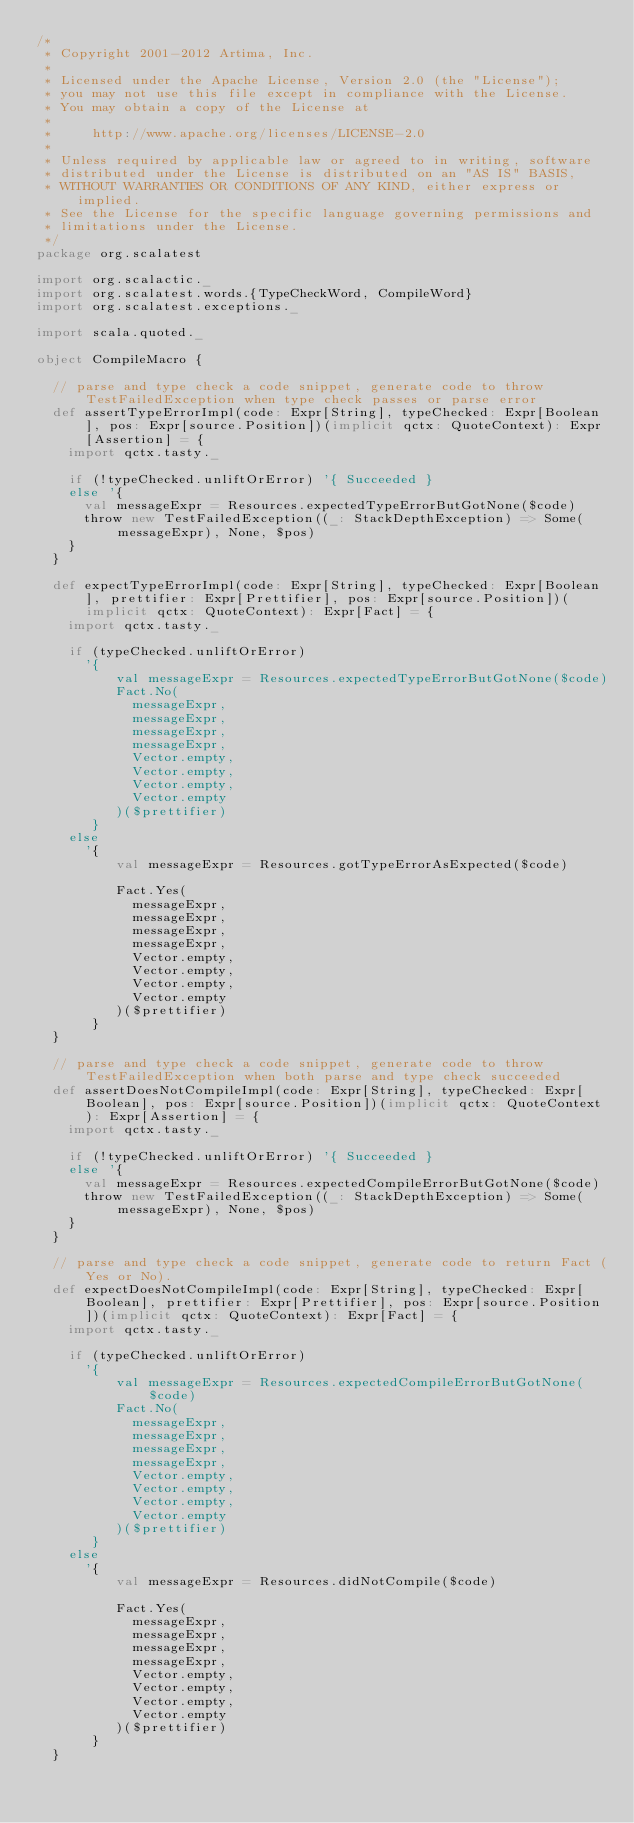<code> <loc_0><loc_0><loc_500><loc_500><_Scala_>/*
 * Copyright 2001-2012 Artima, Inc.
 *
 * Licensed under the Apache License, Version 2.0 (the "License");
 * you may not use this file except in compliance with the License.
 * You may obtain a copy of the License at
 *
 *     http://www.apache.org/licenses/LICENSE-2.0
 *
 * Unless required by applicable law or agreed to in writing, software
 * distributed under the License is distributed on an "AS IS" BASIS,
 * WITHOUT WARRANTIES OR CONDITIONS OF ANY KIND, either express or implied.
 * See the License for the specific language governing permissions and
 * limitations under the License.
 */
package org.scalatest

import org.scalactic._
import org.scalatest.words.{TypeCheckWord, CompileWord}
import org.scalatest.exceptions._

import scala.quoted._

object CompileMacro {

  // parse and type check a code snippet, generate code to throw TestFailedException when type check passes or parse error
  def assertTypeErrorImpl(code: Expr[String], typeChecked: Expr[Boolean], pos: Expr[source.Position])(implicit qctx: QuoteContext): Expr[Assertion] = {
    import qctx.tasty._

    if (!typeChecked.unliftOrError) '{ Succeeded }
    else '{
      val messageExpr = Resources.expectedTypeErrorButGotNone($code)
      throw new TestFailedException((_: StackDepthException) => Some(messageExpr), None, $pos)
    }
  }

  def expectTypeErrorImpl(code: Expr[String], typeChecked: Expr[Boolean], prettifier: Expr[Prettifier], pos: Expr[source.Position])(implicit qctx: QuoteContext): Expr[Fact] = {
    import qctx.tasty._

    if (typeChecked.unliftOrError)
      '{
          val messageExpr = Resources.expectedTypeErrorButGotNone($code)
          Fact.No(
            messageExpr,
            messageExpr,
            messageExpr,
            messageExpr,
            Vector.empty,
            Vector.empty,
            Vector.empty,
            Vector.empty
          )($prettifier)
       }
    else
      '{
          val messageExpr = Resources.gotTypeErrorAsExpected($code)

          Fact.Yes(
            messageExpr,
            messageExpr,
            messageExpr,
            messageExpr,
            Vector.empty,
            Vector.empty,
            Vector.empty,
            Vector.empty
          )($prettifier)
       }
  }

  // parse and type check a code snippet, generate code to throw TestFailedException when both parse and type check succeeded
  def assertDoesNotCompileImpl(code: Expr[String], typeChecked: Expr[Boolean], pos: Expr[source.Position])(implicit qctx: QuoteContext): Expr[Assertion] = {
    import qctx.tasty._

    if (!typeChecked.unliftOrError) '{ Succeeded }
    else '{
      val messageExpr = Resources.expectedCompileErrorButGotNone($code)
      throw new TestFailedException((_: StackDepthException) => Some(messageExpr), None, $pos)
    }
  }

  // parse and type check a code snippet, generate code to return Fact (Yes or No).
  def expectDoesNotCompileImpl(code: Expr[String], typeChecked: Expr[Boolean], prettifier: Expr[Prettifier], pos: Expr[source.Position])(implicit qctx: QuoteContext): Expr[Fact] = {
    import qctx.tasty._

    if (typeChecked.unliftOrError)
      '{
          val messageExpr = Resources.expectedCompileErrorButGotNone($code)
          Fact.No(
            messageExpr,
            messageExpr,
            messageExpr,
            messageExpr,
            Vector.empty,
            Vector.empty,
            Vector.empty,
            Vector.empty
          )($prettifier)
       }
    else
      '{
          val messageExpr = Resources.didNotCompile($code)

          Fact.Yes(
            messageExpr,
            messageExpr,
            messageExpr,
            messageExpr,
            Vector.empty,
            Vector.empty,
            Vector.empty,
            Vector.empty
          )($prettifier)
       }
  }
</code> 